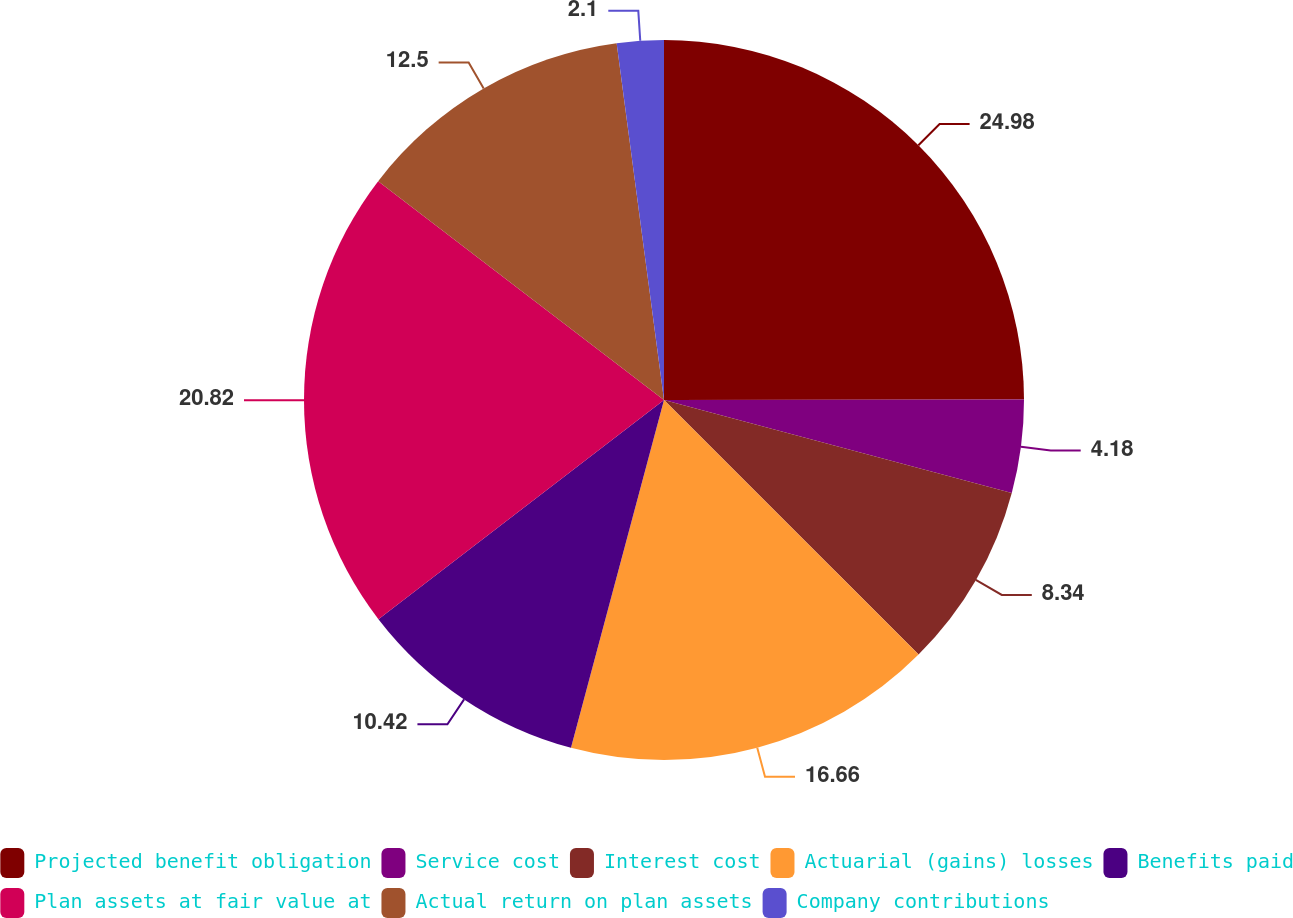Convert chart to OTSL. <chart><loc_0><loc_0><loc_500><loc_500><pie_chart><fcel>Projected benefit obligation<fcel>Service cost<fcel>Interest cost<fcel>Actuarial (gains) losses<fcel>Benefits paid<fcel>Plan assets at fair value at<fcel>Actual return on plan assets<fcel>Company contributions<nl><fcel>24.98%<fcel>4.18%<fcel>8.34%<fcel>16.66%<fcel>10.42%<fcel>20.82%<fcel>12.5%<fcel>2.1%<nl></chart> 